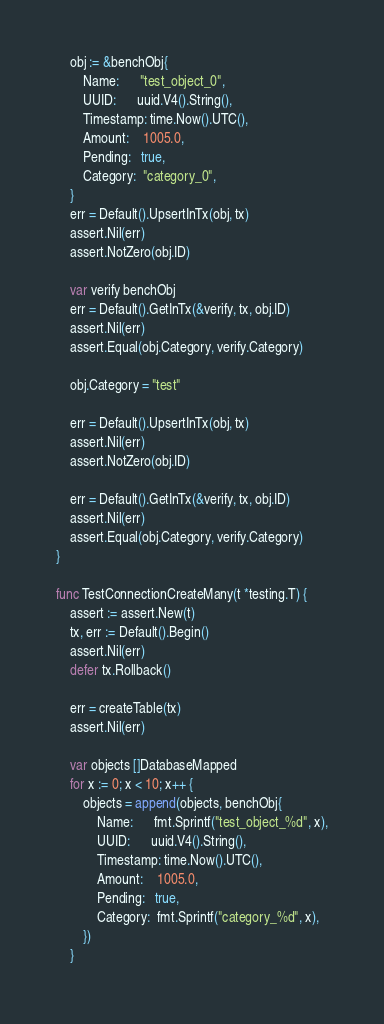Convert code to text. <code><loc_0><loc_0><loc_500><loc_500><_Go_>	obj := &benchObj{
		Name:      "test_object_0",
		UUID:      uuid.V4().String(),
		Timestamp: time.Now().UTC(),
		Amount:    1005.0,
		Pending:   true,
		Category:  "category_0",
	}
	err = Default().UpsertInTx(obj, tx)
	assert.Nil(err)
	assert.NotZero(obj.ID)

	var verify benchObj
	err = Default().GetInTx(&verify, tx, obj.ID)
	assert.Nil(err)
	assert.Equal(obj.Category, verify.Category)

	obj.Category = "test"

	err = Default().UpsertInTx(obj, tx)
	assert.Nil(err)
	assert.NotZero(obj.ID)

	err = Default().GetInTx(&verify, tx, obj.ID)
	assert.Nil(err)
	assert.Equal(obj.Category, verify.Category)
}

func TestConnectionCreateMany(t *testing.T) {
	assert := assert.New(t)
	tx, err := Default().Begin()
	assert.Nil(err)
	defer tx.Rollback()

	err = createTable(tx)
	assert.Nil(err)

	var objects []DatabaseMapped
	for x := 0; x < 10; x++ {
		objects = append(objects, benchObj{
			Name:      fmt.Sprintf("test_object_%d", x),
			UUID:      uuid.V4().String(),
			Timestamp: time.Now().UTC(),
			Amount:    1005.0,
			Pending:   true,
			Category:  fmt.Sprintf("category_%d", x),
		})
	}
</code> 